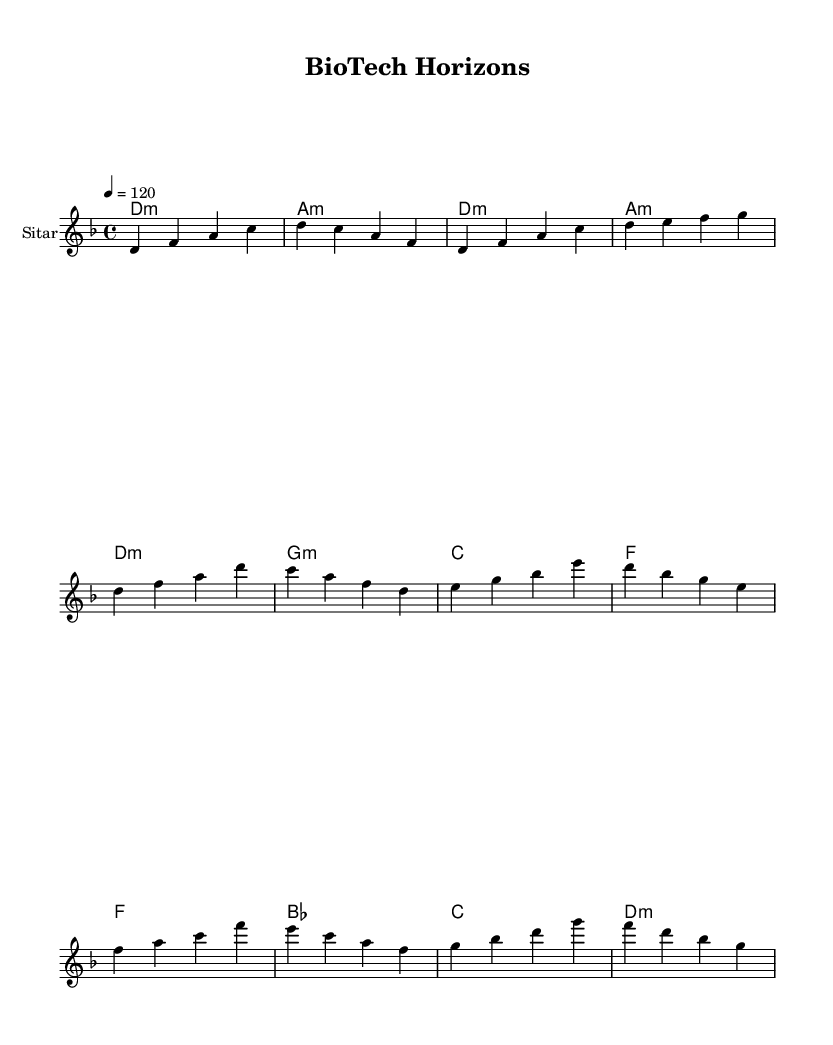What is the key signature of this music? The key signature is represented by the beginning of the piece, where it indicates D minor, which includes one flat (B flat).
Answer: D minor What is the time signature of this music? The time signature is found at the beginning of the score, noted as four beats in each measure, which is represented as 4/4.
Answer: 4/4 What is the tempo marking for this piece? The tempo marking is indicated in the score with a metronome marking, which reads 120 beats per minute.
Answer: 120 Which instrument is featured in this score? The instrument is specified in the score layout, where it states that the melody is to be played on the sitar.
Answer: Sitar How many measures are in the verse section? By counting the measures in the verse section from the provided melody, there are eight measures total.
Answer: Eight measures What is the first chord played in the introduction? The first chord is noted at the beginning of the piece, which is labeled as D minor.
Answer: D minor What type of music genre does this piece represent? The structure and instrumentation along with the blending of elements indicate that this piece is categorized under contemporary fusion.
Answer: Contemporary fusion 